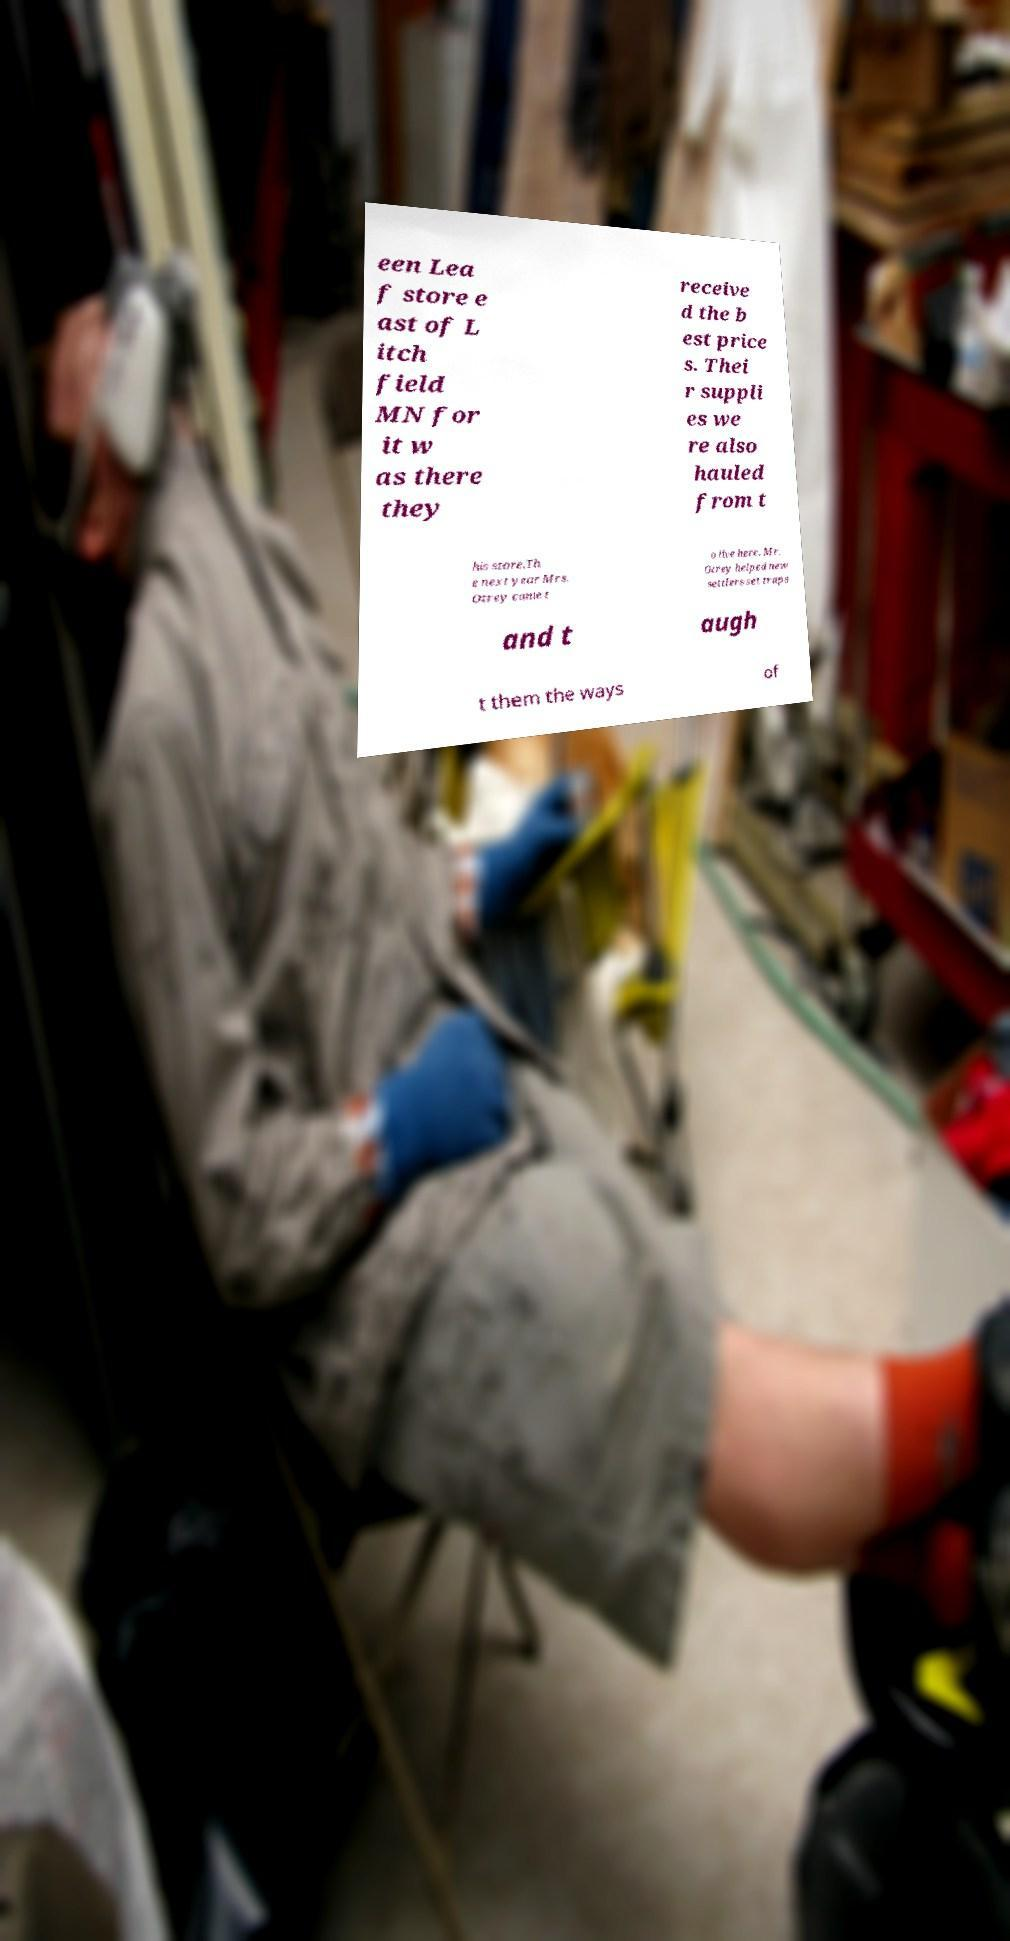Could you assist in decoding the text presented in this image and type it out clearly? een Lea f store e ast of L itch field MN for it w as there they receive d the b est price s. Thei r suppli es we re also hauled from t his store.Th e next year Mrs. Otrey came t o live here. Mr. Otrey helped new settlers set traps and t augh t them the ways of 